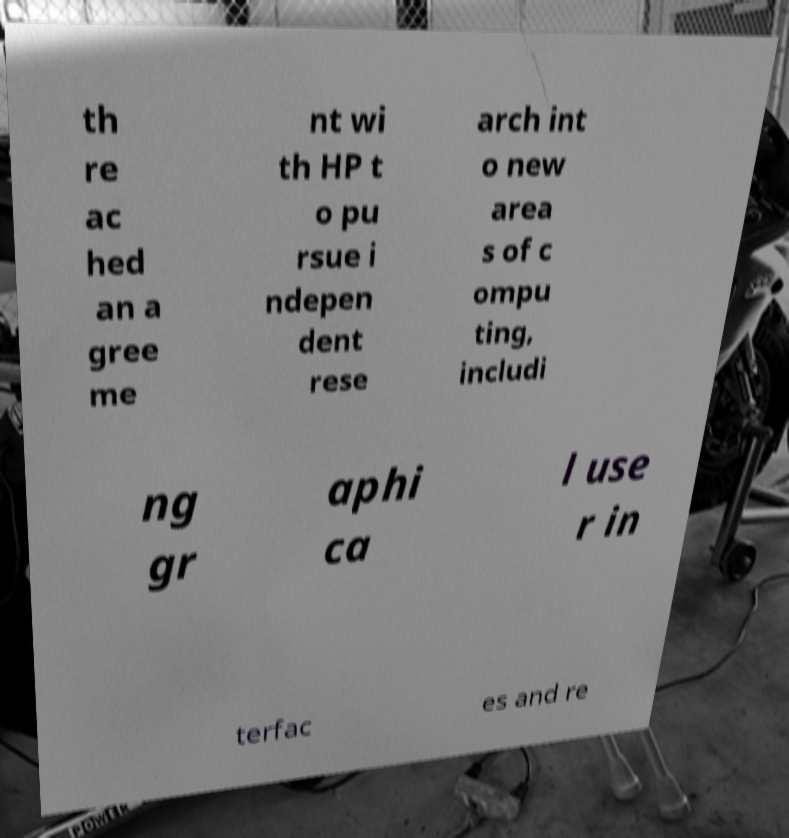Please identify and transcribe the text found in this image. th re ac hed an a gree me nt wi th HP t o pu rsue i ndepen dent rese arch int o new area s of c ompu ting, includi ng gr aphi ca l use r in terfac es and re 